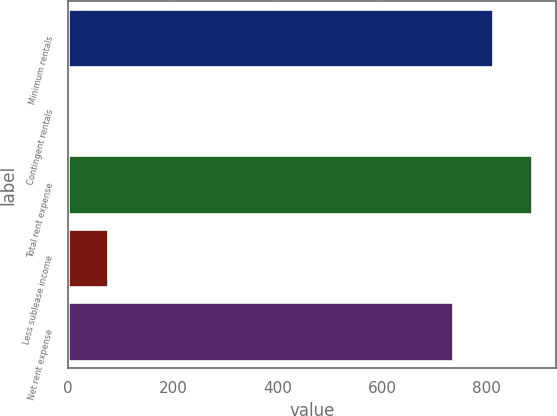<chart> <loc_0><loc_0><loc_500><loc_500><bar_chart><fcel>Minimum rentals<fcel>Contingent rentals<fcel>Total rent expense<fcel>Less sublease income<fcel>Net rent expense<nl><fcel>811.7<fcel>1<fcel>887.4<fcel>76.7<fcel>736<nl></chart> 